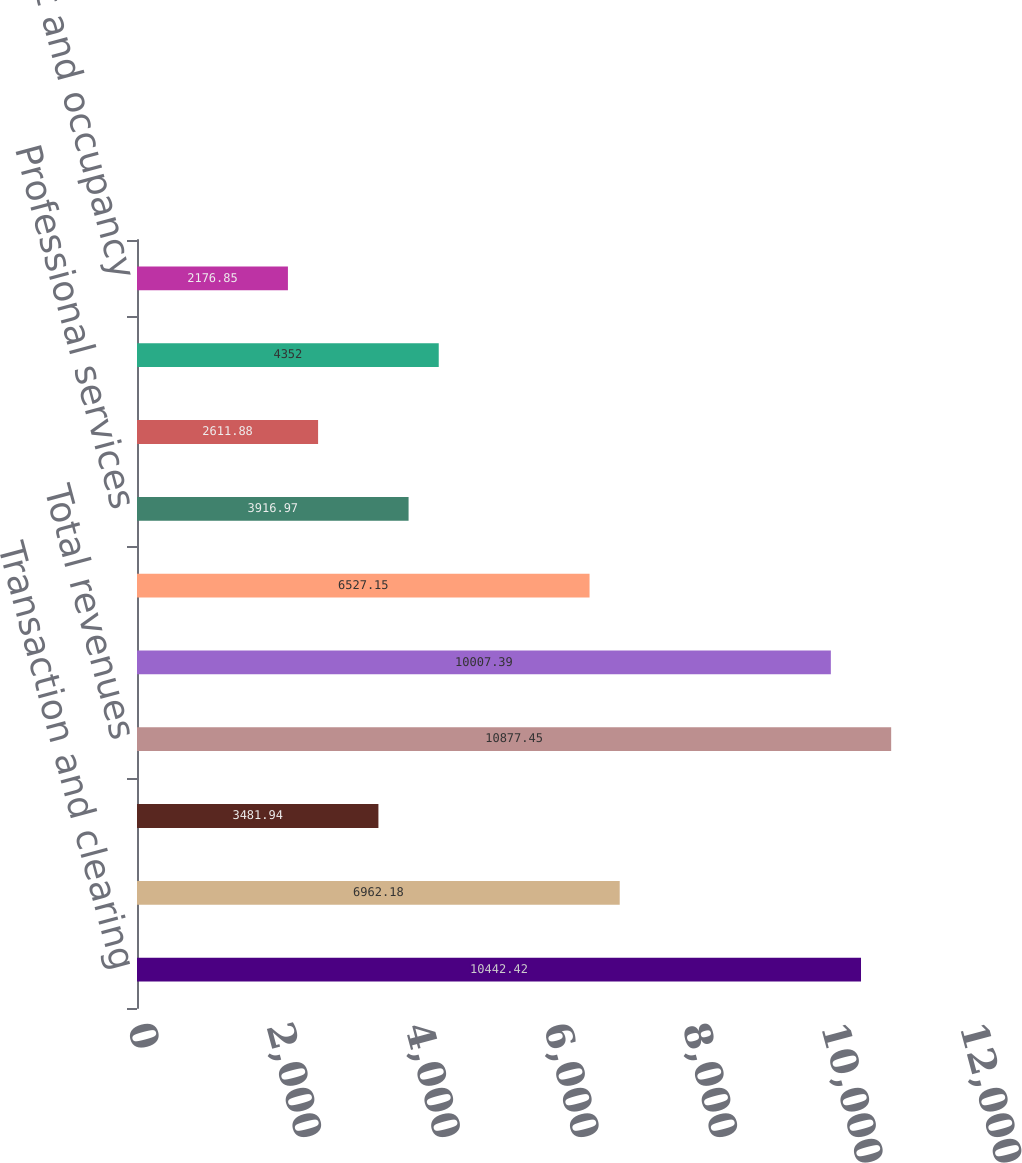Convert chart. <chart><loc_0><loc_0><loc_500><loc_500><bar_chart><fcel>Transaction and clearing<fcel>Data services<fcel>Other revenues<fcel>Total revenues<fcel>Total revenues less<fcel>Compensation and benefits<fcel>Professional services<fcel>Acquisition-related<fcel>Technology and communication<fcel>Rent and occupancy<nl><fcel>10442.4<fcel>6962.18<fcel>3481.94<fcel>10877.5<fcel>10007.4<fcel>6527.15<fcel>3916.97<fcel>2611.88<fcel>4352<fcel>2176.85<nl></chart> 